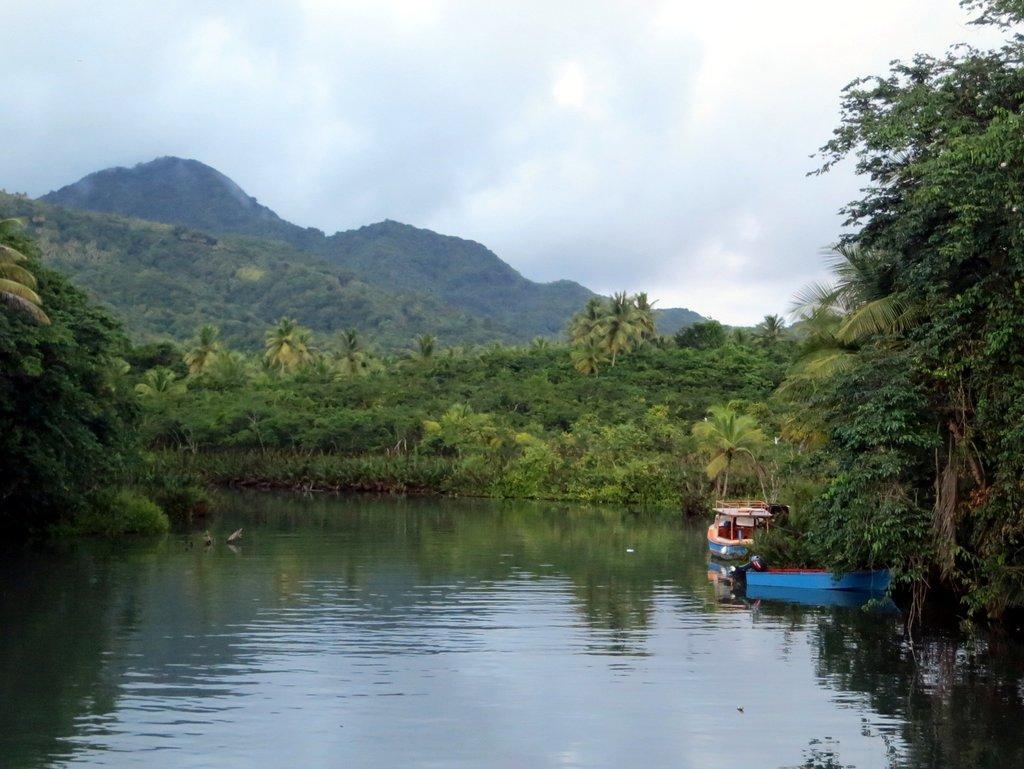Can you describe this image briefly? In this picture we can see there are two boats on the water. Behind the boats there are trees, hills and the cloudy sky. 